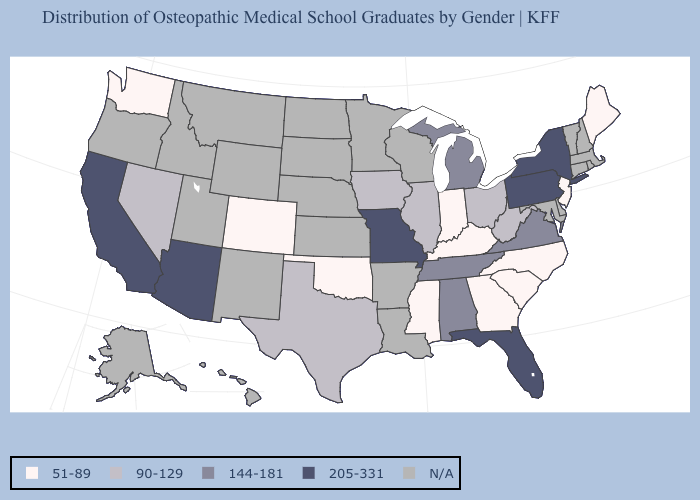Does Indiana have the lowest value in the MidWest?
Short answer required. Yes. Which states have the lowest value in the USA?
Concise answer only. Colorado, Georgia, Indiana, Kentucky, Maine, Mississippi, New Jersey, North Carolina, Oklahoma, South Carolina, Washington. Is the legend a continuous bar?
Concise answer only. No. What is the value of Virginia?
Write a very short answer. 144-181. Name the states that have a value in the range 205-331?
Keep it brief. Arizona, California, Florida, Missouri, New York, Pennsylvania. Name the states that have a value in the range 90-129?
Be succinct. Illinois, Iowa, Nevada, Ohio, Texas, West Virginia. What is the value of Pennsylvania?
Quick response, please. 205-331. What is the lowest value in the USA?
Quick response, please. 51-89. What is the value of South Carolina?
Quick response, please. 51-89. Which states hav the highest value in the MidWest?
Give a very brief answer. Missouri. Which states have the highest value in the USA?
Concise answer only. Arizona, California, Florida, Missouri, New York, Pennsylvania. Name the states that have a value in the range 51-89?
Concise answer only. Colorado, Georgia, Indiana, Kentucky, Maine, Mississippi, New Jersey, North Carolina, Oklahoma, South Carolina, Washington. Name the states that have a value in the range 90-129?
Give a very brief answer. Illinois, Iowa, Nevada, Ohio, Texas, West Virginia. 